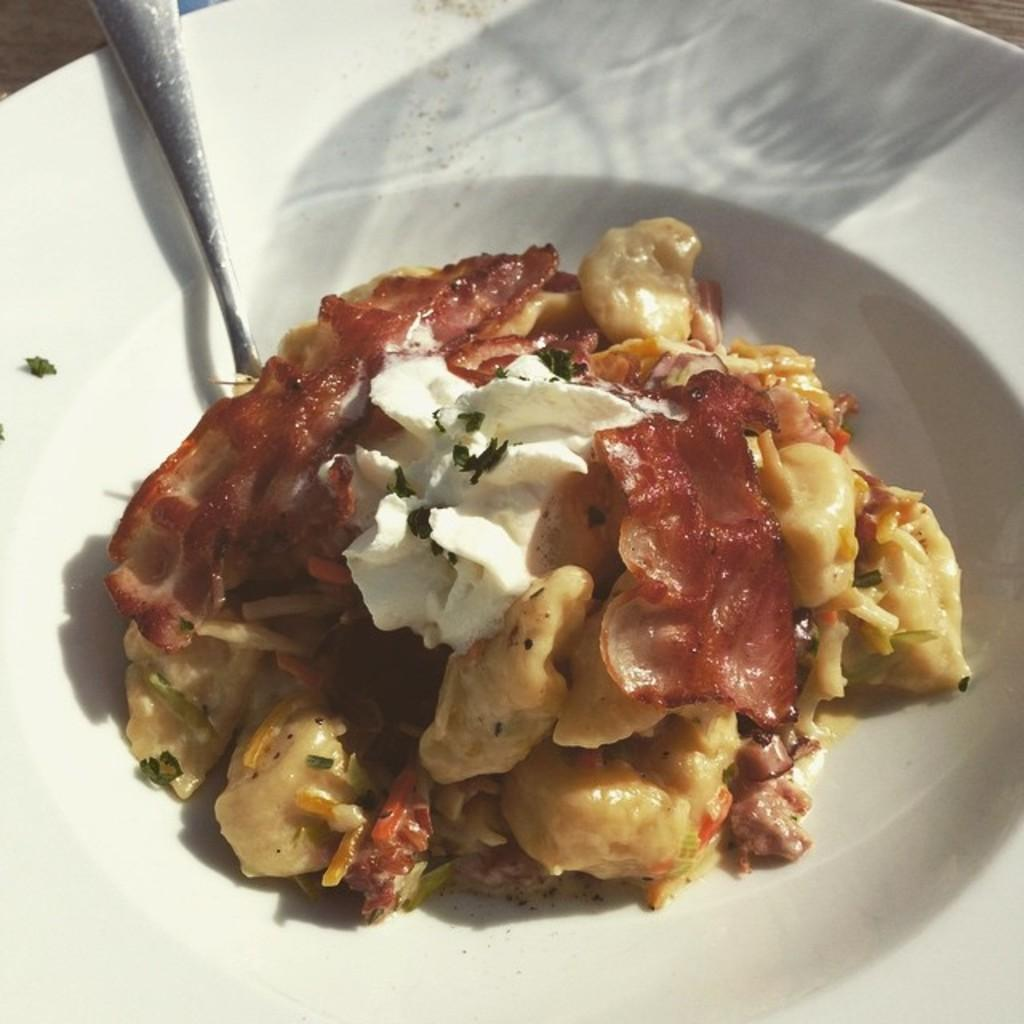What type of food can be seen in the image? There is pasta in the image. How is the pasta presented? The pasta is on a plate. What is the color of the plate? The plate has a white color. What is on top of the pasta? There is cream on top of the pasta. What utensil is present in the image? There is a spoon in the image. What type of force is being applied to the pasta in the image? There is no force being applied to the pasta in the image; it is simply presented on a plate with cream on top. 